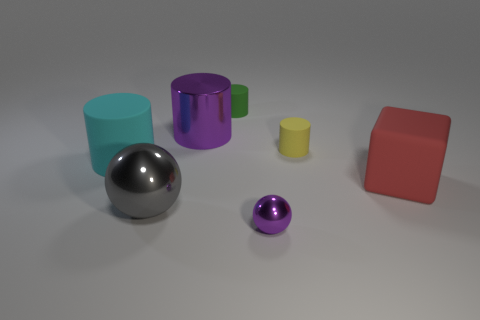Subtract all cyan cylinders. Subtract all yellow balls. How many cylinders are left? 3 Add 2 spheres. How many objects exist? 9 Subtract all blocks. How many objects are left? 6 Add 3 yellow rubber things. How many yellow rubber things exist? 4 Subtract 1 yellow cylinders. How many objects are left? 6 Subtract all small red metallic balls. Subtract all large cylinders. How many objects are left? 5 Add 3 big metal spheres. How many big metal spheres are left? 4 